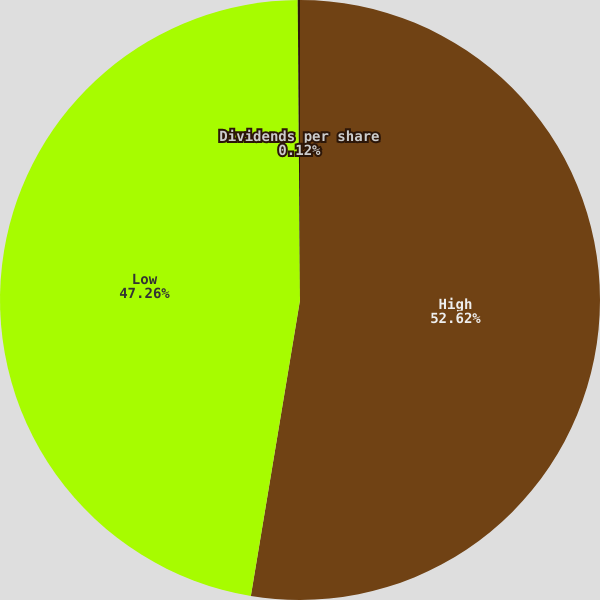Convert chart. <chart><loc_0><loc_0><loc_500><loc_500><pie_chart><fcel>High<fcel>Low<fcel>Dividends per share<nl><fcel>52.62%<fcel>47.26%<fcel>0.12%<nl></chart> 